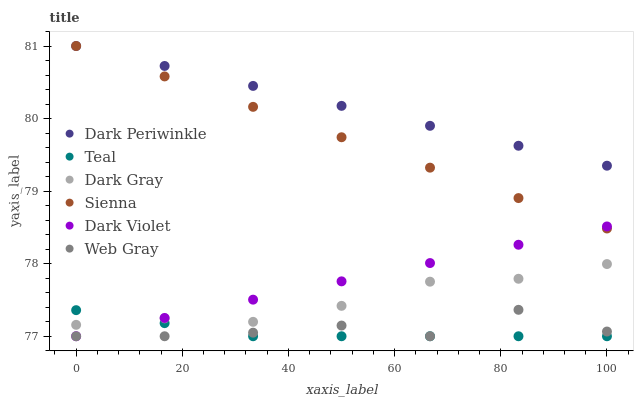Does Teal have the minimum area under the curve?
Answer yes or no. Yes. Does Dark Periwinkle have the maximum area under the curve?
Answer yes or no. Yes. Does Web Gray have the minimum area under the curve?
Answer yes or no. No. Does Web Gray have the maximum area under the curve?
Answer yes or no. No. Is Sienna the smoothest?
Answer yes or no. Yes. Is Web Gray the roughest?
Answer yes or no. Yes. Is Dark Violet the smoothest?
Answer yes or no. No. Is Dark Violet the roughest?
Answer yes or no. No. Does Web Gray have the lowest value?
Answer yes or no. Yes. Does Dark Gray have the lowest value?
Answer yes or no. No. Does Dark Periwinkle have the highest value?
Answer yes or no. Yes. Does Web Gray have the highest value?
Answer yes or no. No. Is Teal less than Sienna?
Answer yes or no. Yes. Is Dark Periwinkle greater than Web Gray?
Answer yes or no. Yes. Does Dark Periwinkle intersect Sienna?
Answer yes or no. Yes. Is Dark Periwinkle less than Sienna?
Answer yes or no. No. Is Dark Periwinkle greater than Sienna?
Answer yes or no. No. Does Teal intersect Sienna?
Answer yes or no. No. 